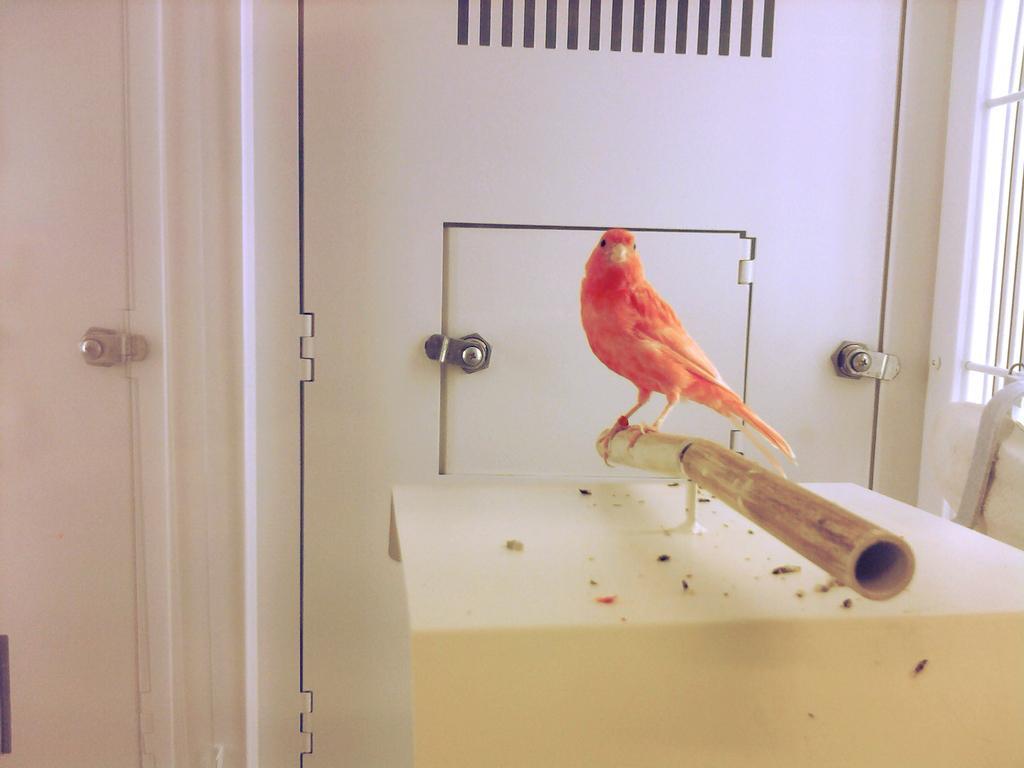How would you summarize this image in a sentence or two? This image consists of a bird in orange color It is standing on a pipe. In the background, there is a door in white color. On the right, it looks like a window. On the left, there is a wall. 